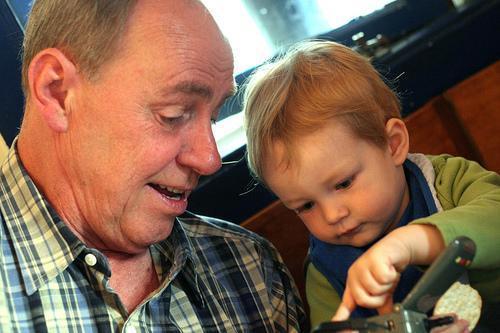How many people are there?
Give a very brief answer. 2. How many cell phones are visible?
Give a very brief answer. 1. How many fences shown in this picture are between the giraffe and the camera?
Give a very brief answer. 0. 